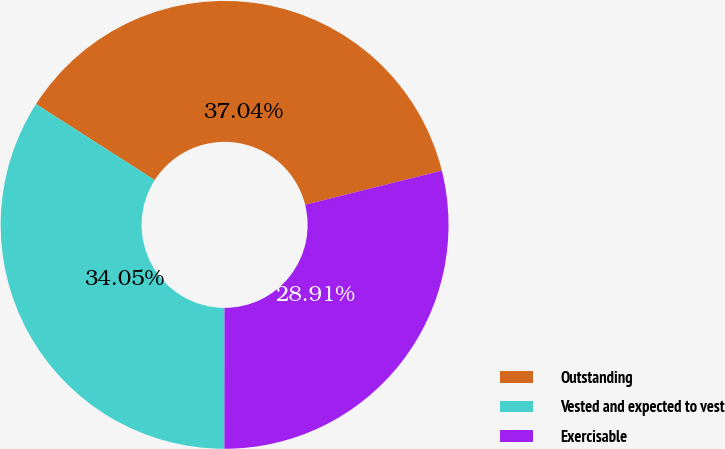<chart> <loc_0><loc_0><loc_500><loc_500><pie_chart><fcel>Outstanding<fcel>Vested and expected to vest<fcel>Exercisable<nl><fcel>37.04%<fcel>34.05%<fcel>28.91%<nl></chart> 